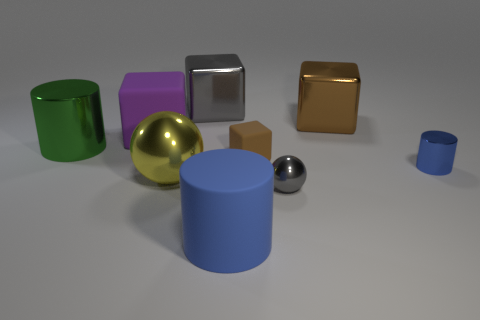Is there anything else of the same color as the tiny cylinder?
Your response must be concise. Yes. How many brown matte objects are the same size as the purple cube?
Your answer should be compact. 0. What is the shape of the big object that is the same color as the tiny cylinder?
Your answer should be compact. Cylinder. There is a metal cylinder on the right side of the purple rubber cube; is its color the same as the big cylinder on the right side of the large matte cube?
Keep it short and to the point. Yes. How many brown cubes are in front of the purple block?
Make the answer very short. 1. There is a shiny cylinder that is the same color as the large rubber cylinder; what size is it?
Your answer should be compact. Small. Are there any other metallic things that have the same shape as the tiny gray metallic object?
Give a very brief answer. Yes. What color is the rubber cube that is the same size as the gray metal cube?
Ensure brevity in your answer.  Purple. Is the number of yellow things that are behind the large brown shiny object less than the number of yellow metal balls that are to the left of the rubber cylinder?
Your answer should be compact. Yes. Is the size of the brown rubber object behind the blue metal cylinder the same as the tiny gray metallic thing?
Offer a very short reply. Yes. 